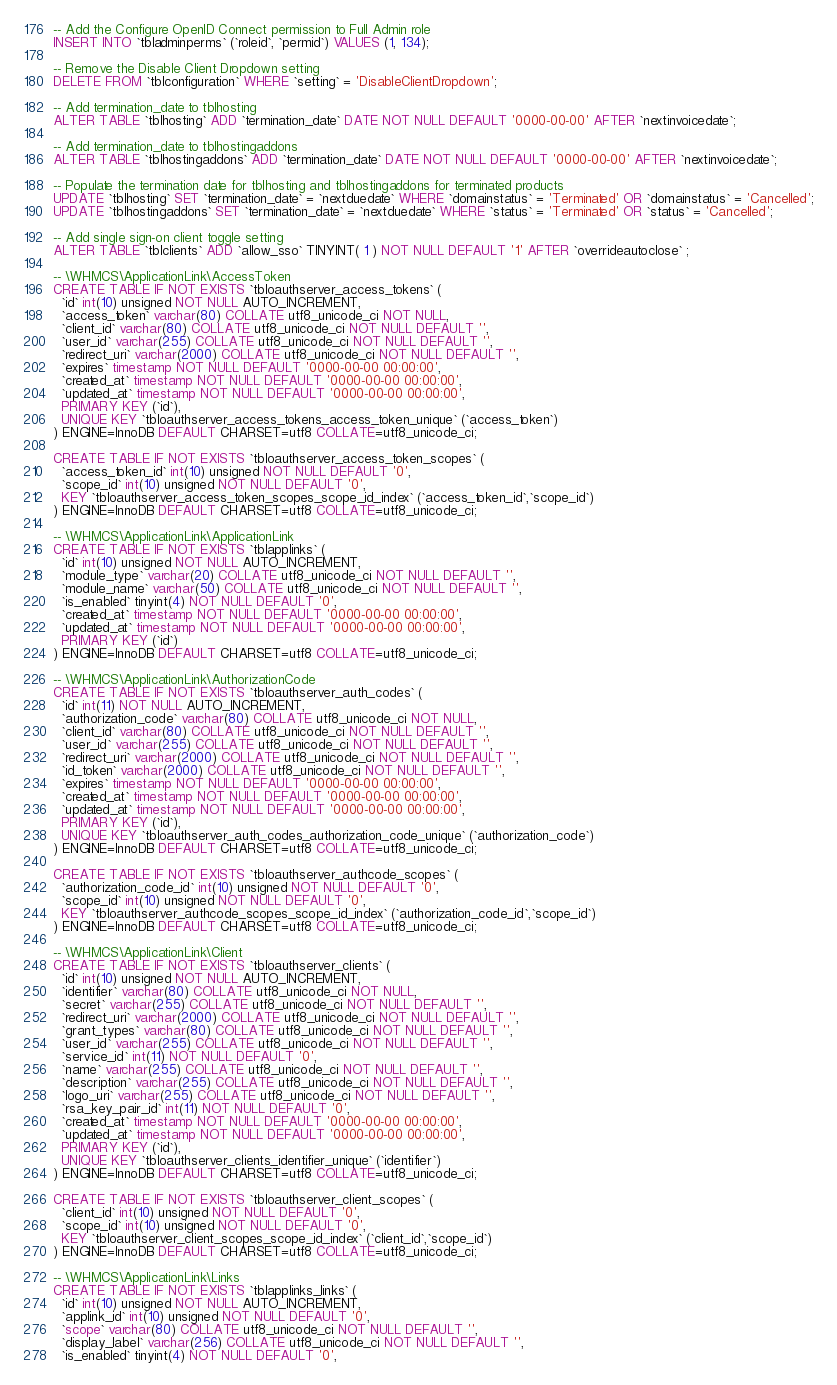<code> <loc_0><loc_0><loc_500><loc_500><_SQL_>-- Add the Configure OpenID Connect permission to Full Admin role
INSERT INTO `tbladminperms` (`roleid`, `permid`) VALUES (1, 134);

-- Remove the Disable Client Dropdown setting
DELETE FROM `tblconfiguration` WHERE `setting` = 'DisableClientDropdown';

-- Add termination_date to tblhosting
ALTER TABLE `tblhosting` ADD `termination_date` DATE NOT NULL DEFAULT '0000-00-00' AFTER `nextinvoicedate`;

-- Add termination_date to tblhostingaddons
ALTER TABLE `tblhostingaddons` ADD `termination_date` DATE NOT NULL DEFAULT '0000-00-00' AFTER `nextinvoicedate`;

-- Populate the termination date for tblhosting and tblhostingaddons for terminated products
UPDATE `tblhosting` SET `termination_date` = `nextduedate` WHERE `domainstatus` = 'Terminated' OR `domainstatus` = 'Cancelled';
UPDATE `tblhostingaddons` SET `termination_date` = `nextduedate` WHERE `status` = 'Terminated' OR `status` = 'Cancelled';

-- Add single sign-on client toggle setting
ALTER TABLE `tblclients` ADD `allow_sso` TINYINT( 1 ) NOT NULL DEFAULT '1' AFTER `overrideautoclose` ;

-- \WHMCS\ApplicationLink\AccessToken
CREATE TABLE IF NOT EXISTS `tbloauthserver_access_tokens` (
  `id` int(10) unsigned NOT NULL AUTO_INCREMENT,
  `access_token` varchar(80) COLLATE utf8_unicode_ci NOT NULL,
  `client_id` varchar(80) COLLATE utf8_unicode_ci NOT NULL DEFAULT '',
  `user_id` varchar(255) COLLATE utf8_unicode_ci NOT NULL DEFAULT '',
  `redirect_uri` varchar(2000) COLLATE utf8_unicode_ci NOT NULL DEFAULT '',
  `expires` timestamp NOT NULL DEFAULT '0000-00-00 00:00:00',
  `created_at` timestamp NOT NULL DEFAULT '0000-00-00 00:00:00',
  `updated_at` timestamp NOT NULL DEFAULT '0000-00-00 00:00:00',
  PRIMARY KEY (`id`),
  UNIQUE KEY `tbloauthserver_access_tokens_access_token_unique` (`access_token`)
) ENGINE=InnoDB DEFAULT CHARSET=utf8 COLLATE=utf8_unicode_ci;

CREATE TABLE IF NOT EXISTS `tbloauthserver_access_token_scopes` (
  `access_token_id` int(10) unsigned NOT NULL DEFAULT '0',
  `scope_id` int(10) unsigned NOT NULL DEFAULT '0',
  KEY `tbloauthserver_access_token_scopes_scope_id_index` (`access_token_id`,`scope_id`)
) ENGINE=InnoDB DEFAULT CHARSET=utf8 COLLATE=utf8_unicode_ci;

-- \WHMCS\ApplicationLink\ApplicationLink
CREATE TABLE IF NOT EXISTS `tblapplinks` (
  `id` int(10) unsigned NOT NULL AUTO_INCREMENT,
  `module_type` varchar(20) COLLATE utf8_unicode_ci NOT NULL DEFAULT '',
  `module_name` varchar(50) COLLATE utf8_unicode_ci NOT NULL DEFAULT '',
  `is_enabled` tinyint(4) NOT NULL DEFAULT '0',
  `created_at` timestamp NOT NULL DEFAULT '0000-00-00 00:00:00',
  `updated_at` timestamp NOT NULL DEFAULT '0000-00-00 00:00:00',
  PRIMARY KEY (`id`)
) ENGINE=InnoDB DEFAULT CHARSET=utf8 COLLATE=utf8_unicode_ci;

-- \WHMCS\ApplicationLink\AuthorizationCode
CREATE TABLE IF NOT EXISTS `tbloauthserver_auth_codes` (
  `id` int(11) NOT NULL AUTO_INCREMENT,
  `authorization_code` varchar(80) COLLATE utf8_unicode_ci NOT NULL,
  `client_id` varchar(80) COLLATE utf8_unicode_ci NOT NULL DEFAULT '',
  `user_id` varchar(255) COLLATE utf8_unicode_ci NOT NULL DEFAULT '',
  `redirect_uri` varchar(2000) COLLATE utf8_unicode_ci NOT NULL DEFAULT '',
  `id_token` varchar(2000) COLLATE utf8_unicode_ci NOT NULL DEFAULT '',
  `expires` timestamp NOT NULL DEFAULT '0000-00-00 00:00:00',
  `created_at` timestamp NOT NULL DEFAULT '0000-00-00 00:00:00',
  `updated_at` timestamp NOT NULL DEFAULT '0000-00-00 00:00:00',
  PRIMARY KEY (`id`),
  UNIQUE KEY `tbloauthserver_auth_codes_authorization_code_unique` (`authorization_code`)
) ENGINE=InnoDB DEFAULT CHARSET=utf8 COLLATE=utf8_unicode_ci;

CREATE TABLE IF NOT EXISTS `tbloauthserver_authcode_scopes` (
  `authorization_code_id` int(10) unsigned NOT NULL DEFAULT '0',
  `scope_id` int(10) unsigned NOT NULL DEFAULT '0',
  KEY `tbloauthserver_authcode_scopes_scope_id_index` (`authorization_code_id`,`scope_id`)
) ENGINE=InnoDB DEFAULT CHARSET=utf8 COLLATE=utf8_unicode_ci;

-- \WHMCS\ApplicationLink\Client
CREATE TABLE IF NOT EXISTS `tbloauthserver_clients` (
  `id` int(10) unsigned NOT NULL AUTO_INCREMENT,
  `identifier` varchar(80) COLLATE utf8_unicode_ci NOT NULL,
  `secret` varchar(255) COLLATE utf8_unicode_ci NOT NULL DEFAULT '',
  `redirect_uri` varchar(2000) COLLATE utf8_unicode_ci NOT NULL DEFAULT '',
  `grant_types` varchar(80) COLLATE utf8_unicode_ci NOT NULL DEFAULT '',
  `user_id` varchar(255) COLLATE utf8_unicode_ci NOT NULL DEFAULT '',
  `service_id` int(11) NOT NULL DEFAULT '0',
  `name` varchar(255) COLLATE utf8_unicode_ci NOT NULL DEFAULT '',
  `description` varchar(255) COLLATE utf8_unicode_ci NOT NULL DEFAULT '',
  `logo_uri` varchar(255) COLLATE utf8_unicode_ci NOT NULL DEFAULT '',
  `rsa_key_pair_id` int(11) NOT NULL DEFAULT '0',
  `created_at` timestamp NOT NULL DEFAULT '0000-00-00 00:00:00',
  `updated_at` timestamp NOT NULL DEFAULT '0000-00-00 00:00:00',
  PRIMARY KEY (`id`),
  UNIQUE KEY `tbloauthserver_clients_identifier_unique` (`identifier`)
) ENGINE=InnoDB DEFAULT CHARSET=utf8 COLLATE=utf8_unicode_ci;

CREATE TABLE IF NOT EXISTS `tbloauthserver_client_scopes` (
  `client_id` int(10) unsigned NOT NULL DEFAULT '0',
  `scope_id` int(10) unsigned NOT NULL DEFAULT '0',
  KEY `tbloauthserver_client_scopes_scope_id_index` (`client_id`,`scope_id`)
) ENGINE=InnoDB DEFAULT CHARSET=utf8 COLLATE=utf8_unicode_ci;

-- \WHMCS\ApplicationLink\Links
CREATE TABLE IF NOT EXISTS `tblapplinks_links` (
  `id` int(10) unsigned NOT NULL AUTO_INCREMENT,
  `applink_id` int(10) unsigned NOT NULL DEFAULT '0',
  `scope` varchar(80) COLLATE utf8_unicode_ci NOT NULL DEFAULT '',
  `display_label` varchar(256) COLLATE utf8_unicode_ci NOT NULL DEFAULT '',
  `is_enabled` tinyint(4) NOT NULL DEFAULT '0',</code> 